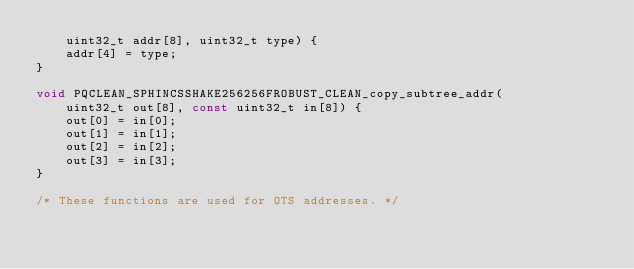Convert code to text. <code><loc_0><loc_0><loc_500><loc_500><_C_>    uint32_t addr[8], uint32_t type) {
    addr[4] = type;
}

void PQCLEAN_SPHINCSSHAKE256256FROBUST_CLEAN_copy_subtree_addr(
    uint32_t out[8], const uint32_t in[8]) {
    out[0] = in[0];
    out[1] = in[1];
    out[2] = in[2];
    out[3] = in[3];
}

/* These functions are used for OTS addresses. */
</code> 